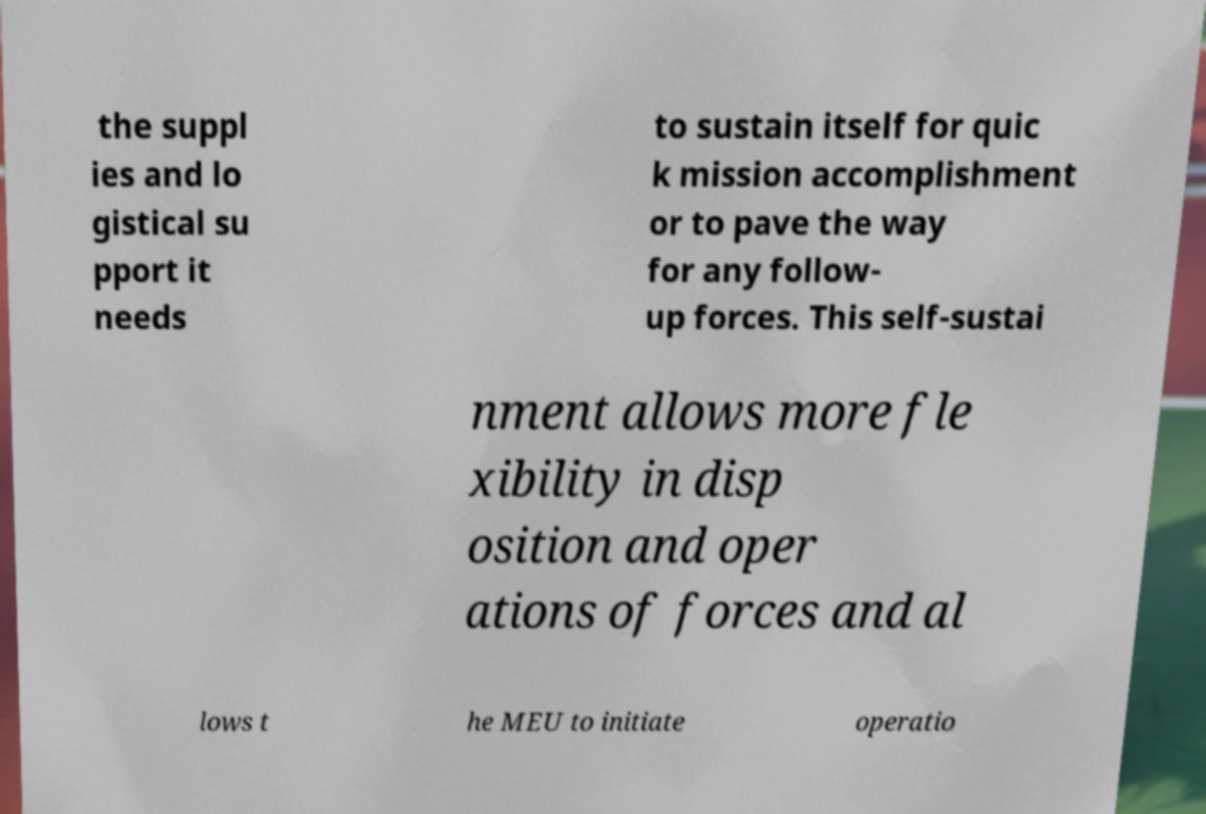There's text embedded in this image that I need extracted. Can you transcribe it verbatim? the suppl ies and lo gistical su pport it needs to sustain itself for quic k mission accomplishment or to pave the way for any follow- up forces. This self-sustai nment allows more fle xibility in disp osition and oper ations of forces and al lows t he MEU to initiate operatio 